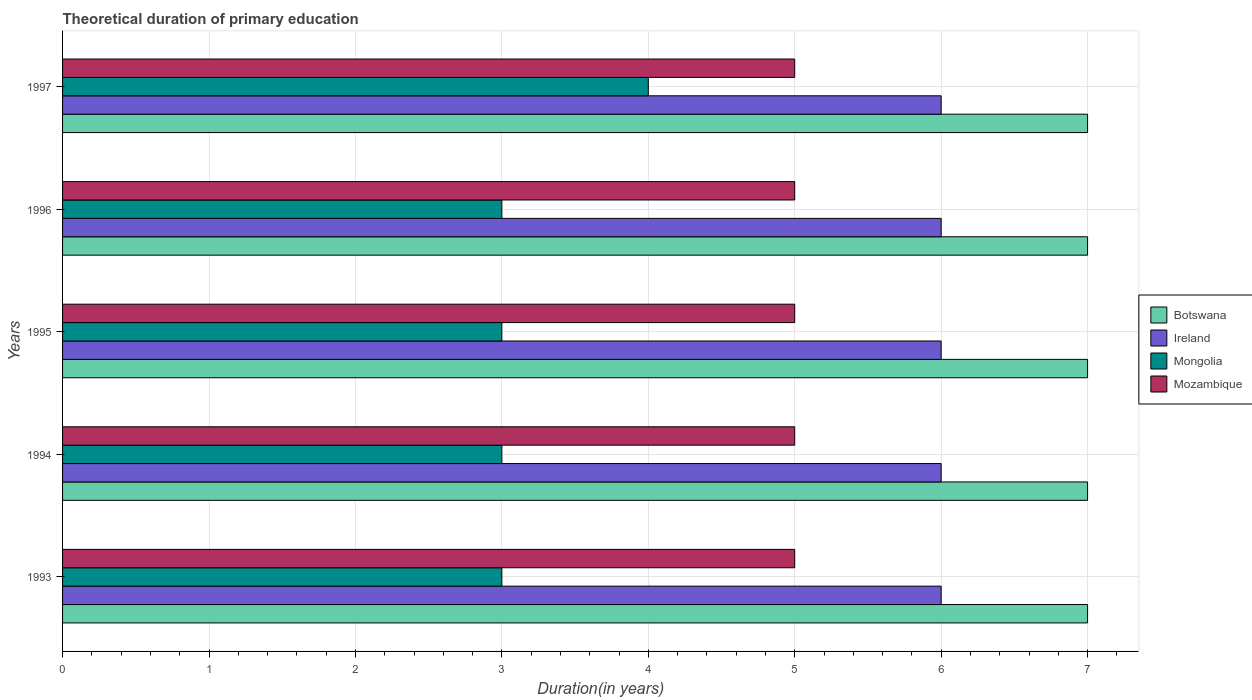How many different coloured bars are there?
Ensure brevity in your answer.  4. How many groups of bars are there?
Provide a short and direct response. 5. Are the number of bars per tick equal to the number of legend labels?
Ensure brevity in your answer.  Yes. What is the label of the 4th group of bars from the top?
Keep it short and to the point. 1994. What is the total theoretical duration of primary education in Mozambique in 1993?
Provide a short and direct response. 5. Across all years, what is the maximum total theoretical duration of primary education in Ireland?
Make the answer very short. 6. Across all years, what is the minimum total theoretical duration of primary education in Ireland?
Make the answer very short. 6. In which year was the total theoretical duration of primary education in Mongolia maximum?
Offer a very short reply. 1997. In which year was the total theoretical duration of primary education in Botswana minimum?
Provide a short and direct response. 1993. What is the total total theoretical duration of primary education in Mozambique in the graph?
Provide a short and direct response. 25. What is the difference between the total theoretical duration of primary education in Mozambique in 1994 and the total theoretical duration of primary education in Ireland in 1996?
Your answer should be very brief. -1. What is the average total theoretical duration of primary education in Mongolia per year?
Your response must be concise. 3.2. In the year 1996, what is the difference between the total theoretical duration of primary education in Botswana and total theoretical duration of primary education in Ireland?
Offer a terse response. 1. Is the difference between the total theoretical duration of primary education in Botswana in 1994 and 1997 greater than the difference between the total theoretical duration of primary education in Ireland in 1994 and 1997?
Your answer should be compact. No. What is the difference between the highest and the second highest total theoretical duration of primary education in Mongolia?
Your answer should be compact. 1. In how many years, is the total theoretical duration of primary education in Botswana greater than the average total theoretical duration of primary education in Botswana taken over all years?
Your answer should be compact. 0. What does the 4th bar from the top in 1993 represents?
Offer a very short reply. Botswana. What does the 3rd bar from the bottom in 1997 represents?
Provide a short and direct response. Mongolia. Is it the case that in every year, the sum of the total theoretical duration of primary education in Mongolia and total theoretical duration of primary education in Ireland is greater than the total theoretical duration of primary education in Botswana?
Offer a terse response. Yes. How many bars are there?
Provide a succinct answer. 20. Are all the bars in the graph horizontal?
Make the answer very short. Yes. What is the difference between two consecutive major ticks on the X-axis?
Make the answer very short. 1. Are the values on the major ticks of X-axis written in scientific E-notation?
Keep it short and to the point. No. Does the graph contain grids?
Make the answer very short. Yes. Where does the legend appear in the graph?
Make the answer very short. Center right. What is the title of the graph?
Your response must be concise. Theoretical duration of primary education. What is the label or title of the X-axis?
Keep it short and to the point. Duration(in years). What is the label or title of the Y-axis?
Provide a succinct answer. Years. What is the Duration(in years) of Ireland in 1993?
Your answer should be very brief. 6. What is the Duration(in years) in Mozambique in 1994?
Your response must be concise. 5. What is the Duration(in years) in Botswana in 1995?
Offer a very short reply. 7. What is the Duration(in years) of Ireland in 1995?
Give a very brief answer. 6. What is the Duration(in years) in Botswana in 1996?
Your answer should be compact. 7. What is the Duration(in years) in Mongolia in 1996?
Provide a short and direct response. 3. What is the Duration(in years) in Botswana in 1997?
Offer a very short reply. 7. What is the Duration(in years) of Ireland in 1997?
Your response must be concise. 6. What is the Duration(in years) in Mongolia in 1997?
Make the answer very short. 4. What is the Duration(in years) in Mozambique in 1997?
Provide a succinct answer. 5. Across all years, what is the maximum Duration(in years) in Ireland?
Ensure brevity in your answer.  6. Across all years, what is the maximum Duration(in years) in Mongolia?
Ensure brevity in your answer.  4. Across all years, what is the maximum Duration(in years) of Mozambique?
Ensure brevity in your answer.  5. Across all years, what is the minimum Duration(in years) in Botswana?
Your answer should be compact. 7. What is the total Duration(in years) of Botswana in the graph?
Provide a succinct answer. 35. What is the total Duration(in years) in Ireland in the graph?
Offer a very short reply. 30. What is the total Duration(in years) in Mongolia in the graph?
Make the answer very short. 16. What is the total Duration(in years) of Mozambique in the graph?
Provide a succinct answer. 25. What is the difference between the Duration(in years) in Ireland in 1993 and that in 1994?
Provide a succinct answer. 0. What is the difference between the Duration(in years) in Mozambique in 1993 and that in 1994?
Ensure brevity in your answer.  0. What is the difference between the Duration(in years) of Ireland in 1993 and that in 1995?
Ensure brevity in your answer.  0. What is the difference between the Duration(in years) of Mongolia in 1993 and that in 1997?
Your answer should be compact. -1. What is the difference between the Duration(in years) of Botswana in 1994 and that in 1995?
Your response must be concise. 0. What is the difference between the Duration(in years) in Ireland in 1994 and that in 1995?
Offer a very short reply. 0. What is the difference between the Duration(in years) in Mongolia in 1994 and that in 1995?
Offer a very short reply. 0. What is the difference between the Duration(in years) of Mozambique in 1994 and that in 1995?
Provide a short and direct response. 0. What is the difference between the Duration(in years) of Botswana in 1994 and that in 1996?
Ensure brevity in your answer.  0. What is the difference between the Duration(in years) in Mozambique in 1994 and that in 1996?
Make the answer very short. 0. What is the difference between the Duration(in years) of Botswana in 1994 and that in 1997?
Your response must be concise. 0. What is the difference between the Duration(in years) of Mongolia in 1994 and that in 1997?
Keep it short and to the point. -1. What is the difference between the Duration(in years) in Botswana in 1995 and that in 1996?
Provide a short and direct response. 0. What is the difference between the Duration(in years) in Ireland in 1995 and that in 1996?
Provide a short and direct response. 0. What is the difference between the Duration(in years) of Mongolia in 1995 and that in 1996?
Make the answer very short. 0. What is the difference between the Duration(in years) in Mozambique in 1995 and that in 1996?
Keep it short and to the point. 0. What is the difference between the Duration(in years) in Mongolia in 1995 and that in 1997?
Provide a short and direct response. -1. What is the difference between the Duration(in years) in Mongolia in 1996 and that in 1997?
Offer a very short reply. -1. What is the difference between the Duration(in years) of Mozambique in 1996 and that in 1997?
Provide a succinct answer. 0. What is the difference between the Duration(in years) of Botswana in 1993 and the Duration(in years) of Ireland in 1994?
Provide a short and direct response. 1. What is the difference between the Duration(in years) of Botswana in 1993 and the Duration(in years) of Mongolia in 1994?
Give a very brief answer. 4. What is the difference between the Duration(in years) in Mongolia in 1993 and the Duration(in years) in Mozambique in 1994?
Keep it short and to the point. -2. What is the difference between the Duration(in years) in Botswana in 1993 and the Duration(in years) in Mongolia in 1995?
Keep it short and to the point. 4. What is the difference between the Duration(in years) of Ireland in 1993 and the Duration(in years) of Mongolia in 1995?
Your answer should be compact. 3. What is the difference between the Duration(in years) of Botswana in 1993 and the Duration(in years) of Ireland in 1996?
Ensure brevity in your answer.  1. What is the difference between the Duration(in years) of Botswana in 1993 and the Duration(in years) of Mongolia in 1996?
Offer a very short reply. 4. What is the difference between the Duration(in years) of Botswana in 1993 and the Duration(in years) of Mongolia in 1997?
Give a very brief answer. 3. What is the difference between the Duration(in years) of Ireland in 1993 and the Duration(in years) of Mongolia in 1997?
Ensure brevity in your answer.  2. What is the difference between the Duration(in years) in Ireland in 1993 and the Duration(in years) in Mozambique in 1997?
Your answer should be very brief. 1. What is the difference between the Duration(in years) of Mongolia in 1993 and the Duration(in years) of Mozambique in 1997?
Your response must be concise. -2. What is the difference between the Duration(in years) of Botswana in 1994 and the Duration(in years) of Ireland in 1995?
Keep it short and to the point. 1. What is the difference between the Duration(in years) of Mongolia in 1994 and the Duration(in years) of Mozambique in 1995?
Provide a short and direct response. -2. What is the difference between the Duration(in years) in Botswana in 1994 and the Duration(in years) in Mongolia in 1996?
Your answer should be very brief. 4. What is the difference between the Duration(in years) of Ireland in 1994 and the Duration(in years) of Mozambique in 1996?
Keep it short and to the point. 1. What is the difference between the Duration(in years) in Mongolia in 1994 and the Duration(in years) in Mozambique in 1996?
Ensure brevity in your answer.  -2. What is the difference between the Duration(in years) in Botswana in 1994 and the Duration(in years) in Ireland in 1997?
Offer a very short reply. 1. What is the difference between the Duration(in years) of Ireland in 1994 and the Duration(in years) of Mozambique in 1997?
Make the answer very short. 1. What is the difference between the Duration(in years) in Botswana in 1995 and the Duration(in years) in Mongolia in 1996?
Your response must be concise. 4. What is the difference between the Duration(in years) of Botswana in 1995 and the Duration(in years) of Ireland in 1997?
Provide a short and direct response. 1. What is the difference between the Duration(in years) in Botswana in 1995 and the Duration(in years) in Mongolia in 1997?
Ensure brevity in your answer.  3. What is the difference between the Duration(in years) of Botswana in 1995 and the Duration(in years) of Mozambique in 1997?
Provide a succinct answer. 2. What is the difference between the Duration(in years) in Ireland in 1995 and the Duration(in years) in Mongolia in 1997?
Make the answer very short. 2. What is the difference between the Duration(in years) in Mongolia in 1995 and the Duration(in years) in Mozambique in 1997?
Give a very brief answer. -2. What is the difference between the Duration(in years) in Botswana in 1996 and the Duration(in years) in Ireland in 1997?
Offer a very short reply. 1. What is the difference between the Duration(in years) of Botswana in 1996 and the Duration(in years) of Mozambique in 1997?
Your answer should be very brief. 2. What is the difference between the Duration(in years) of Ireland in 1996 and the Duration(in years) of Mongolia in 1997?
Provide a succinct answer. 2. What is the average Duration(in years) of Ireland per year?
Give a very brief answer. 6. What is the average Duration(in years) of Mozambique per year?
Offer a very short reply. 5. In the year 1993, what is the difference between the Duration(in years) in Botswana and Duration(in years) in Mongolia?
Your response must be concise. 4. In the year 1993, what is the difference between the Duration(in years) of Ireland and Duration(in years) of Mongolia?
Offer a terse response. 3. In the year 1993, what is the difference between the Duration(in years) in Ireland and Duration(in years) in Mozambique?
Offer a very short reply. 1. In the year 1993, what is the difference between the Duration(in years) of Mongolia and Duration(in years) of Mozambique?
Make the answer very short. -2. In the year 1994, what is the difference between the Duration(in years) in Ireland and Duration(in years) in Mongolia?
Make the answer very short. 3. In the year 1994, what is the difference between the Duration(in years) of Ireland and Duration(in years) of Mozambique?
Provide a short and direct response. 1. In the year 1994, what is the difference between the Duration(in years) of Mongolia and Duration(in years) of Mozambique?
Give a very brief answer. -2. In the year 1995, what is the difference between the Duration(in years) in Botswana and Duration(in years) in Mozambique?
Ensure brevity in your answer.  2. In the year 1995, what is the difference between the Duration(in years) of Ireland and Duration(in years) of Mongolia?
Offer a terse response. 3. In the year 1995, what is the difference between the Duration(in years) in Mongolia and Duration(in years) in Mozambique?
Your answer should be compact. -2. In the year 1996, what is the difference between the Duration(in years) in Ireland and Duration(in years) in Mongolia?
Ensure brevity in your answer.  3. In the year 1996, what is the difference between the Duration(in years) in Ireland and Duration(in years) in Mozambique?
Your answer should be compact. 1. In the year 1997, what is the difference between the Duration(in years) in Botswana and Duration(in years) in Ireland?
Provide a succinct answer. 1. In the year 1997, what is the difference between the Duration(in years) of Botswana and Duration(in years) of Mongolia?
Your answer should be compact. 3. In the year 1997, what is the difference between the Duration(in years) in Ireland and Duration(in years) in Mongolia?
Your answer should be compact. 2. In the year 1997, what is the difference between the Duration(in years) in Ireland and Duration(in years) in Mozambique?
Provide a short and direct response. 1. What is the ratio of the Duration(in years) of Ireland in 1993 to that in 1994?
Keep it short and to the point. 1. What is the ratio of the Duration(in years) in Mongolia in 1993 to that in 1994?
Give a very brief answer. 1. What is the ratio of the Duration(in years) in Botswana in 1993 to that in 1995?
Make the answer very short. 1. What is the ratio of the Duration(in years) in Mongolia in 1993 to that in 1995?
Ensure brevity in your answer.  1. What is the ratio of the Duration(in years) of Botswana in 1993 to that in 1996?
Provide a succinct answer. 1. What is the ratio of the Duration(in years) of Ireland in 1993 to that in 1996?
Give a very brief answer. 1. What is the ratio of the Duration(in years) of Ireland in 1993 to that in 1997?
Provide a short and direct response. 1. What is the ratio of the Duration(in years) of Ireland in 1994 to that in 1995?
Keep it short and to the point. 1. What is the ratio of the Duration(in years) in Mongolia in 1994 to that in 1995?
Offer a very short reply. 1. What is the ratio of the Duration(in years) of Mozambique in 1994 to that in 1996?
Your answer should be compact. 1. What is the ratio of the Duration(in years) in Ireland in 1994 to that in 1997?
Offer a terse response. 1. What is the ratio of the Duration(in years) of Mongolia in 1994 to that in 1997?
Offer a very short reply. 0.75. What is the ratio of the Duration(in years) of Mozambique in 1994 to that in 1997?
Your answer should be compact. 1. What is the ratio of the Duration(in years) in Botswana in 1995 to that in 1996?
Your response must be concise. 1. What is the ratio of the Duration(in years) in Ireland in 1995 to that in 1996?
Give a very brief answer. 1. What is the ratio of the Duration(in years) of Ireland in 1995 to that in 1997?
Your response must be concise. 1. What is the ratio of the Duration(in years) of Botswana in 1996 to that in 1997?
Provide a succinct answer. 1. What is the ratio of the Duration(in years) of Ireland in 1996 to that in 1997?
Keep it short and to the point. 1. What is the ratio of the Duration(in years) of Mozambique in 1996 to that in 1997?
Keep it short and to the point. 1. What is the difference between the highest and the second highest Duration(in years) in Botswana?
Offer a terse response. 0. What is the difference between the highest and the second highest Duration(in years) of Ireland?
Provide a short and direct response. 0. What is the difference between the highest and the second highest Duration(in years) of Mongolia?
Offer a terse response. 1. What is the difference between the highest and the second highest Duration(in years) of Mozambique?
Keep it short and to the point. 0. What is the difference between the highest and the lowest Duration(in years) in Botswana?
Provide a succinct answer. 0. What is the difference between the highest and the lowest Duration(in years) in Ireland?
Offer a terse response. 0. What is the difference between the highest and the lowest Duration(in years) of Mongolia?
Provide a succinct answer. 1. What is the difference between the highest and the lowest Duration(in years) of Mozambique?
Offer a very short reply. 0. 